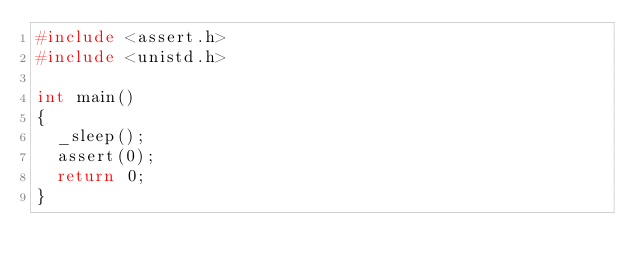Convert code to text. <code><loc_0><loc_0><loc_500><loc_500><_C_>#include <assert.h>
#include <unistd.h>

int main()
{
  _sleep();
  assert(0);
  return 0;
}
</code> 